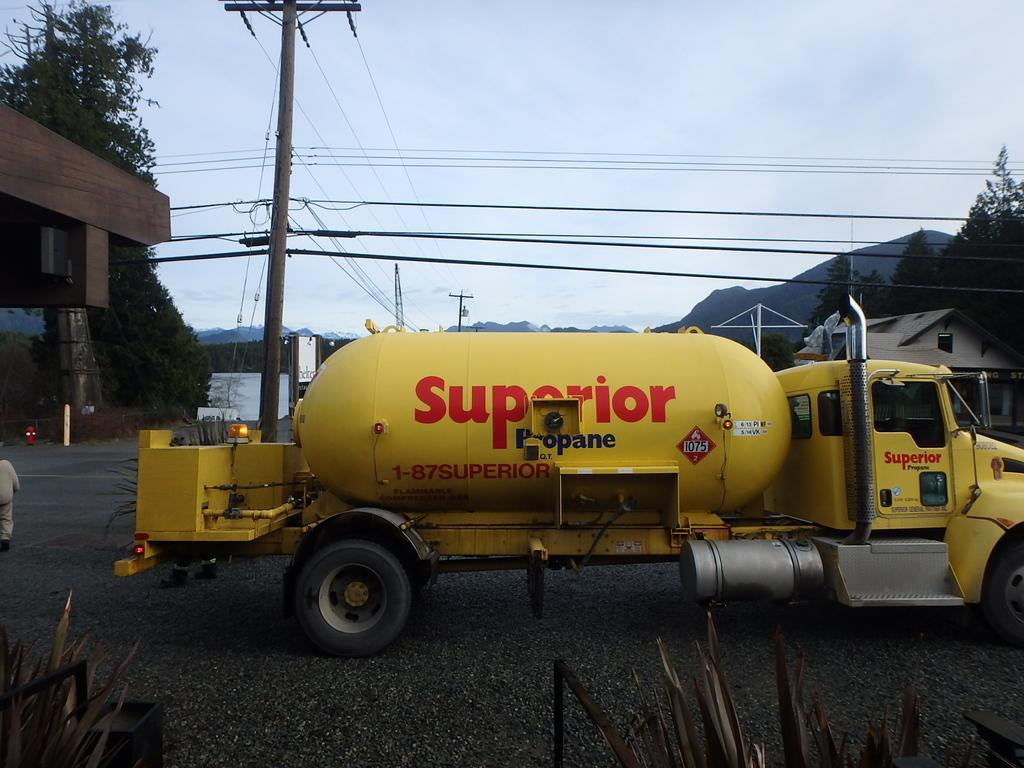Please provide a concise description of this image. In the foreground of this image, there is a vehicle on the road. At the bottom, there are leaves. On the left, there is a man, a building and the trees. On the right, there is a house, few trees and cables. In the background, there are poles, cables, mountains and the sky. 